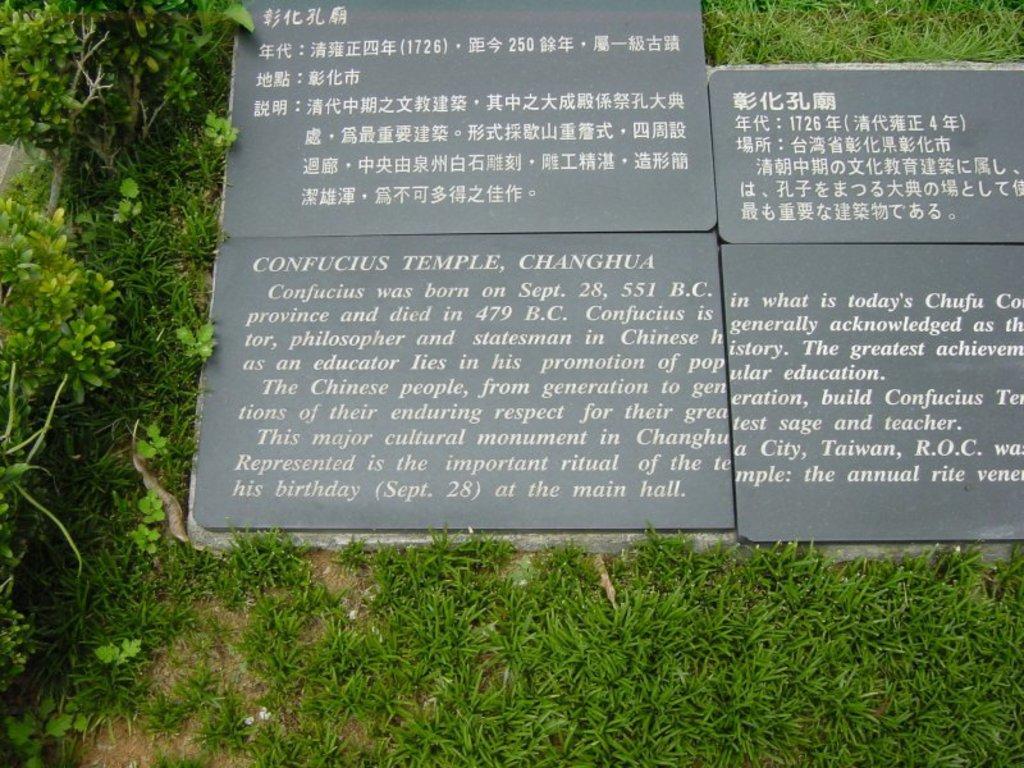Describe this image in one or two sentences. In this picture we can see text on the marble, and we can find few plants. 